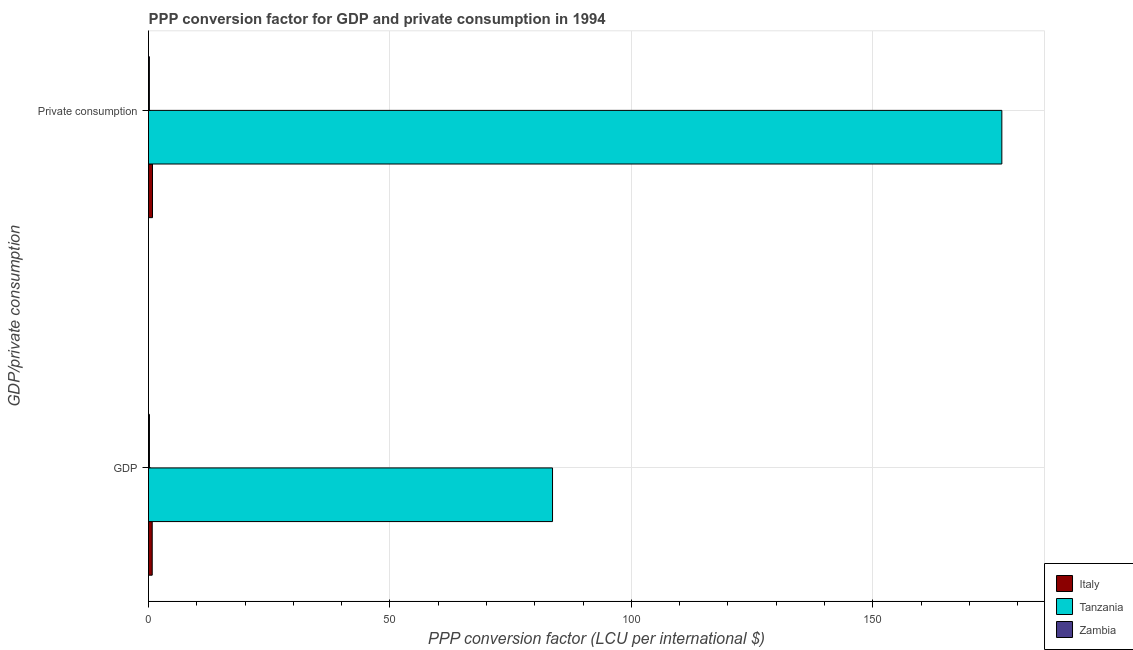How many different coloured bars are there?
Ensure brevity in your answer.  3. How many groups of bars are there?
Offer a terse response. 2. Are the number of bars per tick equal to the number of legend labels?
Your answer should be compact. Yes. How many bars are there on the 2nd tick from the top?
Give a very brief answer. 3. What is the label of the 2nd group of bars from the top?
Give a very brief answer. GDP. What is the ppp conversion factor for gdp in Tanzania?
Offer a very short reply. 83.67. Across all countries, what is the maximum ppp conversion factor for private consumption?
Offer a very short reply. 176.73. Across all countries, what is the minimum ppp conversion factor for gdp?
Your answer should be very brief. 0.19. In which country was the ppp conversion factor for private consumption maximum?
Provide a short and direct response. Tanzania. In which country was the ppp conversion factor for gdp minimum?
Keep it short and to the point. Zambia. What is the total ppp conversion factor for gdp in the graph?
Offer a terse response. 84.63. What is the difference between the ppp conversion factor for gdp in Tanzania and that in Zambia?
Provide a succinct answer. 83.48. What is the difference between the ppp conversion factor for gdp in Zambia and the ppp conversion factor for private consumption in Italy?
Provide a succinct answer. -0.63. What is the average ppp conversion factor for private consumption per country?
Give a very brief answer. 59.24. What is the difference between the ppp conversion factor for gdp and ppp conversion factor for private consumption in Italy?
Ensure brevity in your answer.  -0.06. What is the ratio of the ppp conversion factor for gdp in Italy to that in Zambia?
Provide a short and direct response. 4.05. Is the ppp conversion factor for private consumption in Italy less than that in Tanzania?
Offer a very short reply. Yes. What does the 1st bar from the top in  Private consumption represents?
Give a very brief answer. Zambia. What does the 3rd bar from the bottom in  Private consumption represents?
Provide a short and direct response. Zambia. How many bars are there?
Your response must be concise. 6. Does the graph contain any zero values?
Provide a succinct answer. No. How many legend labels are there?
Your answer should be very brief. 3. What is the title of the graph?
Provide a succinct answer. PPP conversion factor for GDP and private consumption in 1994. What is the label or title of the X-axis?
Your response must be concise. PPP conversion factor (LCU per international $). What is the label or title of the Y-axis?
Ensure brevity in your answer.  GDP/private consumption. What is the PPP conversion factor (LCU per international $) of Italy in GDP?
Provide a succinct answer. 0.77. What is the PPP conversion factor (LCU per international $) of Tanzania in GDP?
Your response must be concise. 83.67. What is the PPP conversion factor (LCU per international $) in Zambia in GDP?
Provide a succinct answer. 0.19. What is the PPP conversion factor (LCU per international $) in Italy in  Private consumption?
Make the answer very short. 0.82. What is the PPP conversion factor (LCU per international $) of Tanzania in  Private consumption?
Give a very brief answer. 176.73. What is the PPP conversion factor (LCU per international $) of Zambia in  Private consumption?
Your answer should be very brief. 0.18. Across all GDP/private consumption, what is the maximum PPP conversion factor (LCU per international $) in Italy?
Provide a succinct answer. 0.82. Across all GDP/private consumption, what is the maximum PPP conversion factor (LCU per international $) of Tanzania?
Offer a terse response. 176.73. Across all GDP/private consumption, what is the maximum PPP conversion factor (LCU per international $) in Zambia?
Offer a very short reply. 0.19. Across all GDP/private consumption, what is the minimum PPP conversion factor (LCU per international $) of Italy?
Your answer should be compact. 0.77. Across all GDP/private consumption, what is the minimum PPP conversion factor (LCU per international $) in Tanzania?
Ensure brevity in your answer.  83.67. Across all GDP/private consumption, what is the minimum PPP conversion factor (LCU per international $) in Zambia?
Give a very brief answer. 0.18. What is the total PPP conversion factor (LCU per international $) in Italy in the graph?
Keep it short and to the point. 1.59. What is the total PPP conversion factor (LCU per international $) in Tanzania in the graph?
Make the answer very short. 260.4. What is the total PPP conversion factor (LCU per international $) of Zambia in the graph?
Provide a short and direct response. 0.37. What is the difference between the PPP conversion factor (LCU per international $) of Italy in GDP and that in  Private consumption?
Provide a short and direct response. -0.06. What is the difference between the PPP conversion factor (LCU per international $) in Tanzania in GDP and that in  Private consumption?
Your response must be concise. -93.06. What is the difference between the PPP conversion factor (LCU per international $) of Zambia in GDP and that in  Private consumption?
Ensure brevity in your answer.  0.01. What is the difference between the PPP conversion factor (LCU per international $) in Italy in GDP and the PPP conversion factor (LCU per international $) in Tanzania in  Private consumption?
Your answer should be compact. -175.96. What is the difference between the PPP conversion factor (LCU per international $) in Italy in GDP and the PPP conversion factor (LCU per international $) in Zambia in  Private consumption?
Provide a succinct answer. 0.59. What is the difference between the PPP conversion factor (LCU per international $) of Tanzania in GDP and the PPP conversion factor (LCU per international $) of Zambia in  Private consumption?
Your answer should be compact. 83.49. What is the average PPP conversion factor (LCU per international $) of Italy per GDP/private consumption?
Offer a very short reply. 0.8. What is the average PPP conversion factor (LCU per international $) in Tanzania per GDP/private consumption?
Make the answer very short. 130.2. What is the average PPP conversion factor (LCU per international $) of Zambia per GDP/private consumption?
Ensure brevity in your answer.  0.18. What is the difference between the PPP conversion factor (LCU per international $) in Italy and PPP conversion factor (LCU per international $) in Tanzania in GDP?
Your response must be concise. -82.9. What is the difference between the PPP conversion factor (LCU per international $) in Italy and PPP conversion factor (LCU per international $) in Zambia in GDP?
Offer a very short reply. 0.58. What is the difference between the PPP conversion factor (LCU per international $) in Tanzania and PPP conversion factor (LCU per international $) in Zambia in GDP?
Keep it short and to the point. 83.48. What is the difference between the PPP conversion factor (LCU per international $) in Italy and PPP conversion factor (LCU per international $) in Tanzania in  Private consumption?
Provide a succinct answer. -175.9. What is the difference between the PPP conversion factor (LCU per international $) in Italy and PPP conversion factor (LCU per international $) in Zambia in  Private consumption?
Keep it short and to the point. 0.64. What is the difference between the PPP conversion factor (LCU per international $) in Tanzania and PPP conversion factor (LCU per international $) in Zambia in  Private consumption?
Your answer should be compact. 176.55. What is the ratio of the PPP conversion factor (LCU per international $) in Italy in GDP to that in  Private consumption?
Your response must be concise. 0.93. What is the ratio of the PPP conversion factor (LCU per international $) of Tanzania in GDP to that in  Private consumption?
Ensure brevity in your answer.  0.47. What is the ratio of the PPP conversion factor (LCU per international $) in Zambia in GDP to that in  Private consumption?
Offer a terse response. 1.06. What is the difference between the highest and the second highest PPP conversion factor (LCU per international $) of Italy?
Give a very brief answer. 0.06. What is the difference between the highest and the second highest PPP conversion factor (LCU per international $) in Tanzania?
Give a very brief answer. 93.06. What is the difference between the highest and the second highest PPP conversion factor (LCU per international $) of Zambia?
Offer a terse response. 0.01. What is the difference between the highest and the lowest PPP conversion factor (LCU per international $) of Italy?
Provide a succinct answer. 0.06. What is the difference between the highest and the lowest PPP conversion factor (LCU per international $) in Tanzania?
Ensure brevity in your answer.  93.06. What is the difference between the highest and the lowest PPP conversion factor (LCU per international $) in Zambia?
Ensure brevity in your answer.  0.01. 